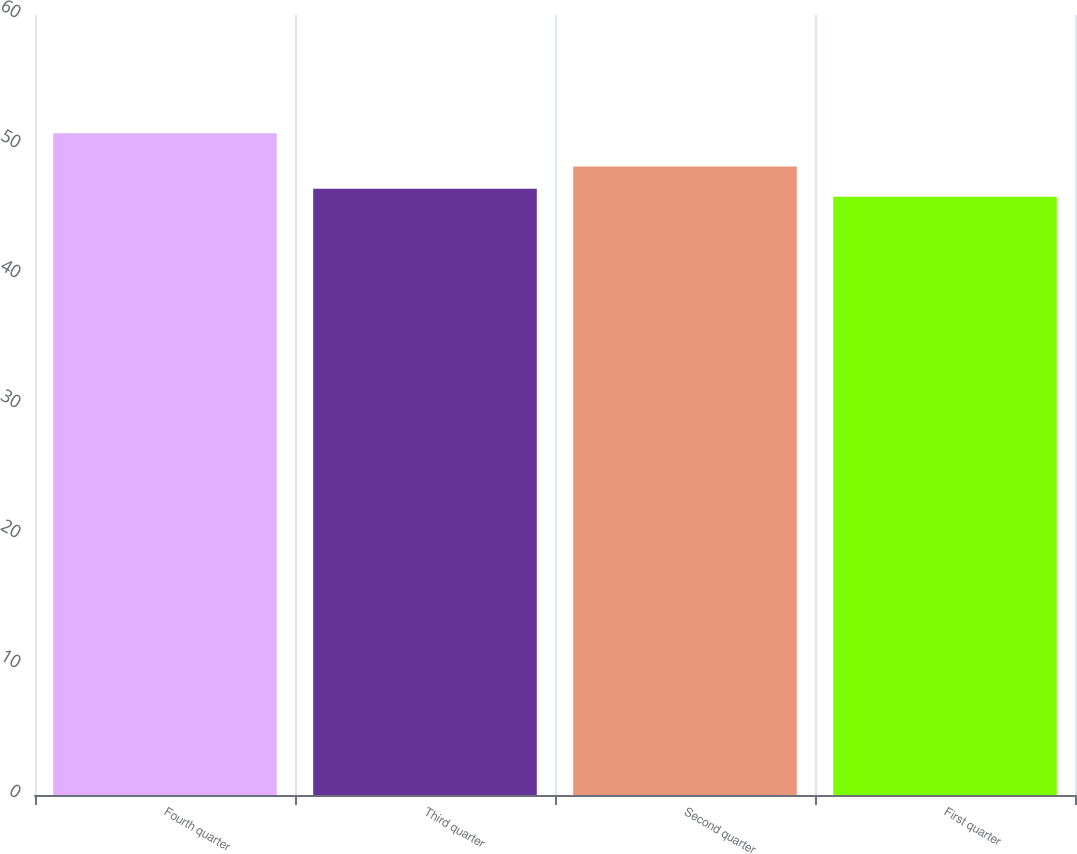Convert chart. <chart><loc_0><loc_0><loc_500><loc_500><bar_chart><fcel>Fourth quarter<fcel>Third quarter<fcel>Second quarter<fcel>First quarter<nl><fcel>50.9<fcel>46.64<fcel>48.34<fcel>46.01<nl></chart> 